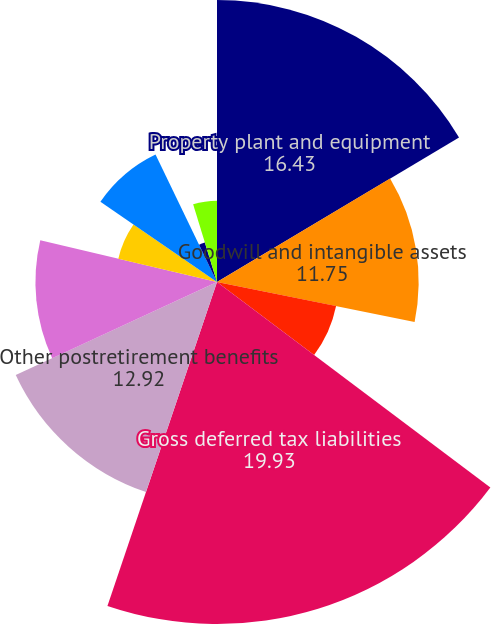Convert chart. <chart><loc_0><loc_0><loc_500><loc_500><pie_chart><fcel>Property plant and equipment<fcel>Goodwill and intangible assets<fcel>Other<fcel>Gross deferred tax liabilities<fcel>Other postretirement benefits<fcel>Pension plans<fcel>Loss and credit carryforwards<fcel>Insurance reserves<fcel>Vacation pay accrual<fcel>Stock compensation<nl><fcel>16.43%<fcel>11.75%<fcel>7.08%<fcel>19.93%<fcel>12.92%<fcel>10.58%<fcel>5.91%<fcel>8.25%<fcel>2.41%<fcel>4.74%<nl></chart> 